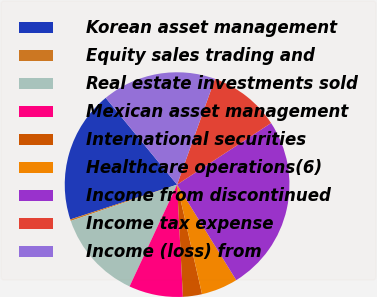<chart> <loc_0><loc_0><loc_500><loc_500><pie_chart><fcel>Korean asset management<fcel>Equity sales trading and<fcel>Real estate investments sold<fcel>Mexican asset management<fcel>International securities<fcel>Healthcare operations(6)<fcel>Income from discontinued<fcel>Income tax expense<fcel>Income (loss) from<nl><fcel>19.06%<fcel>0.22%<fcel>12.81%<fcel>7.78%<fcel>2.74%<fcel>5.26%<fcel>25.41%<fcel>10.3%<fcel>16.43%<nl></chart> 